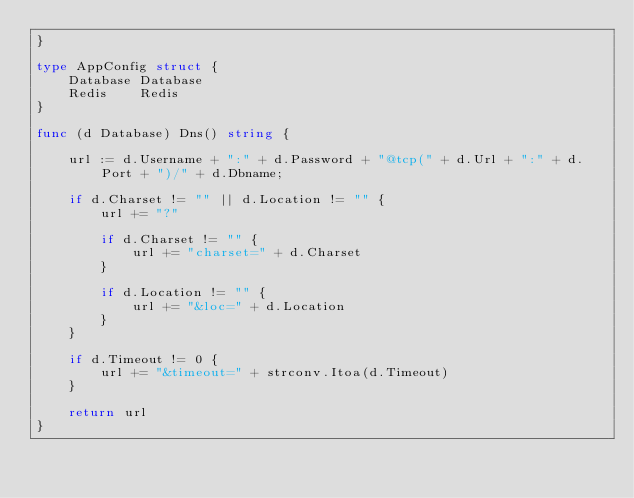Convert code to text. <code><loc_0><loc_0><loc_500><loc_500><_Go_>}

type AppConfig struct {
	Database Database
	Redis    Redis
}

func (d Database) Dns() string {

	url := d.Username + ":" + d.Password + "@tcp(" + d.Url + ":" + d.Port + ")/" + d.Dbname;

	if d.Charset != "" || d.Location != "" {
		url += "?"

		if d.Charset != "" {
			url += "charset=" + d.Charset
		}

		if d.Location != "" {
			url += "&loc=" + d.Location
		}
	}

	if d.Timeout != 0 {
		url += "&timeout=" + strconv.Itoa(d.Timeout)
	}

	return url
}
</code> 